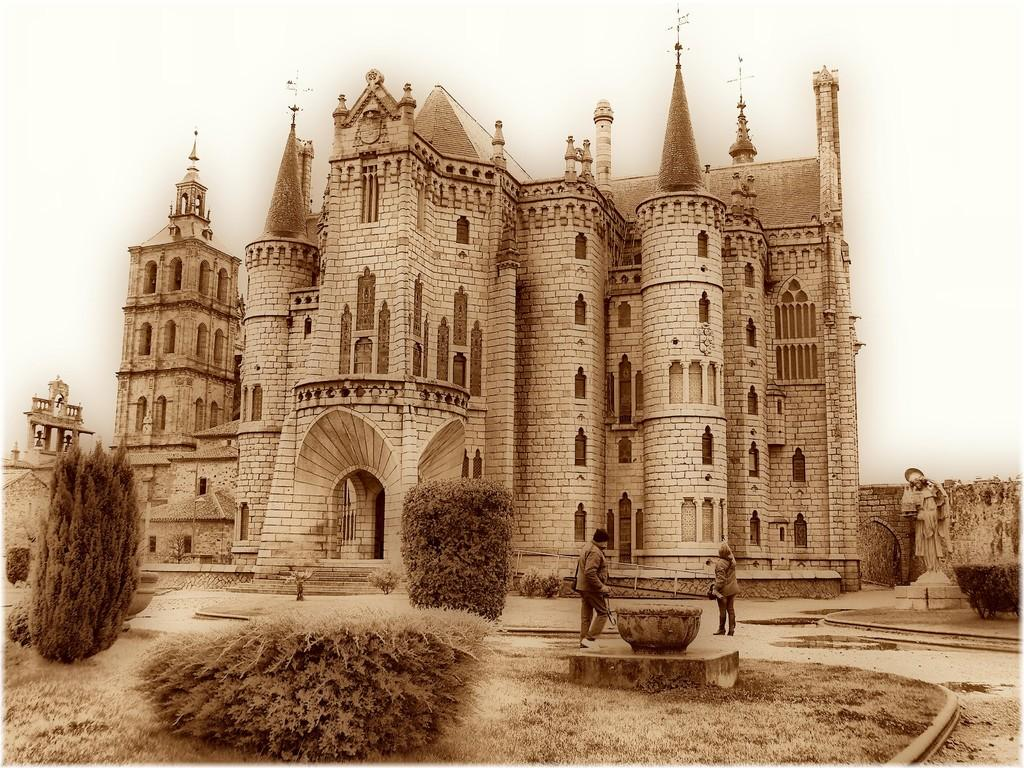How many people are present in the image? There are two people on the ground in the image. What type of structure can be seen in the image? There is a building in the image. What kind of vegetation is visible in the image? There are plants and trees in the image. Can you describe any objects present in the image? There are some objects in the image. What is visible in the background of the image? The sky is visible in the background of the image. How many kitties are playing with the people in the image? There are no kitties present in the image; it only features two people and other elements mentioned in the facts. 